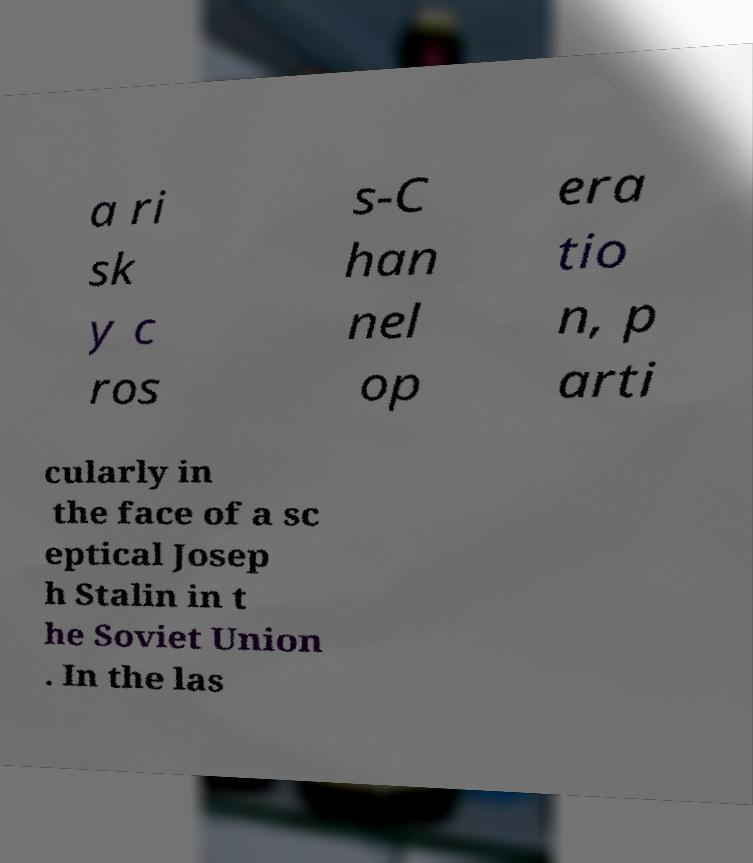Please read and relay the text visible in this image. What does it say? a ri sk y c ros s-C han nel op era tio n, p arti cularly in the face of a sc eptical Josep h Stalin in t he Soviet Union . In the las 